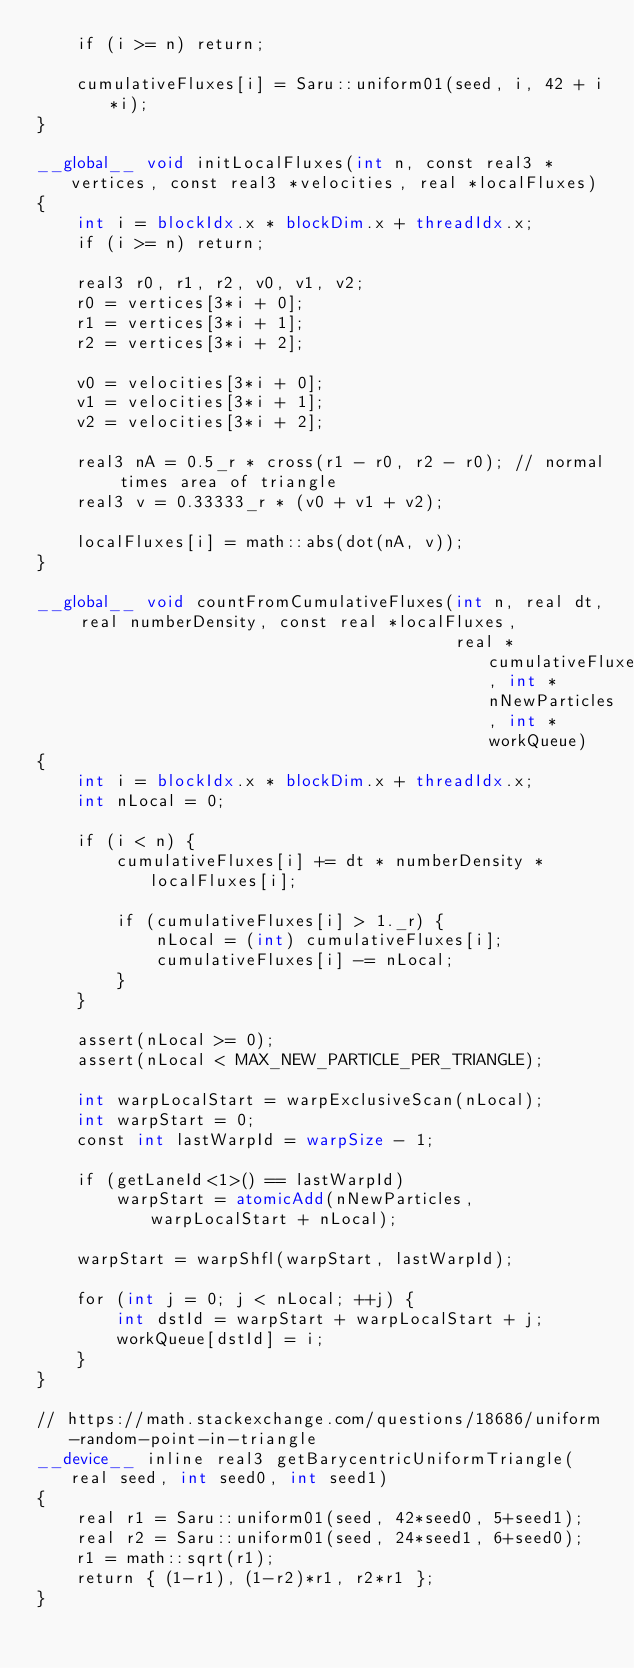<code> <loc_0><loc_0><loc_500><loc_500><_Cuda_>    if (i >= n) return;

    cumulativeFluxes[i] = Saru::uniform01(seed, i, 42 + i*i);
}

__global__ void initLocalFluxes(int n, const real3 *vertices, const real3 *velocities, real *localFluxes)
{
    int i = blockIdx.x * blockDim.x + threadIdx.x;
    if (i >= n) return;

    real3 r0, r1, r2, v0, v1, v2;
    r0 = vertices[3*i + 0];
    r1 = vertices[3*i + 1];
    r2 = vertices[3*i + 2];

    v0 = velocities[3*i + 0];
    v1 = velocities[3*i + 1];
    v2 = velocities[3*i + 2];

    real3 nA = 0.5_r * cross(r1 - r0, r2 - r0); // normal times area of triangle
    real3 v = 0.33333_r * (v0 + v1 + v2);

    localFluxes[i] = math::abs(dot(nA, v));
}

__global__ void countFromCumulativeFluxes(int n, real dt, real numberDensity, const real *localFluxes,
                                          real *cumulativeFluxes, int *nNewParticles, int *workQueue)
{
    int i = blockIdx.x * blockDim.x + threadIdx.x;
    int nLocal = 0;

    if (i < n) {
        cumulativeFluxes[i] += dt * numberDensity * localFluxes[i];

        if (cumulativeFluxes[i] > 1._r) {
            nLocal = (int) cumulativeFluxes[i];
            cumulativeFluxes[i] -= nLocal;
        }
    }

    assert(nLocal >= 0);
    assert(nLocal < MAX_NEW_PARTICLE_PER_TRIANGLE);

    int warpLocalStart = warpExclusiveScan(nLocal);
    int warpStart = 0;
    const int lastWarpId = warpSize - 1;

    if (getLaneId<1>() == lastWarpId)
        warpStart = atomicAdd(nNewParticles, warpLocalStart + nLocal);

    warpStart = warpShfl(warpStart, lastWarpId);

    for (int j = 0; j < nLocal; ++j) {
        int dstId = warpStart + warpLocalStart + j;
        workQueue[dstId] = i;
    }
}

// https://math.stackexchange.com/questions/18686/uniform-random-point-in-triangle
__device__ inline real3 getBarycentricUniformTriangle(real seed, int seed0, int seed1)
{
    real r1 = Saru::uniform01(seed, 42*seed0, 5+seed1);
    real r2 = Saru::uniform01(seed, 24*seed1, 6+seed0);
    r1 = math::sqrt(r1);
    return { (1-r1), (1-r2)*r1, r2*r1 };
}
</code> 